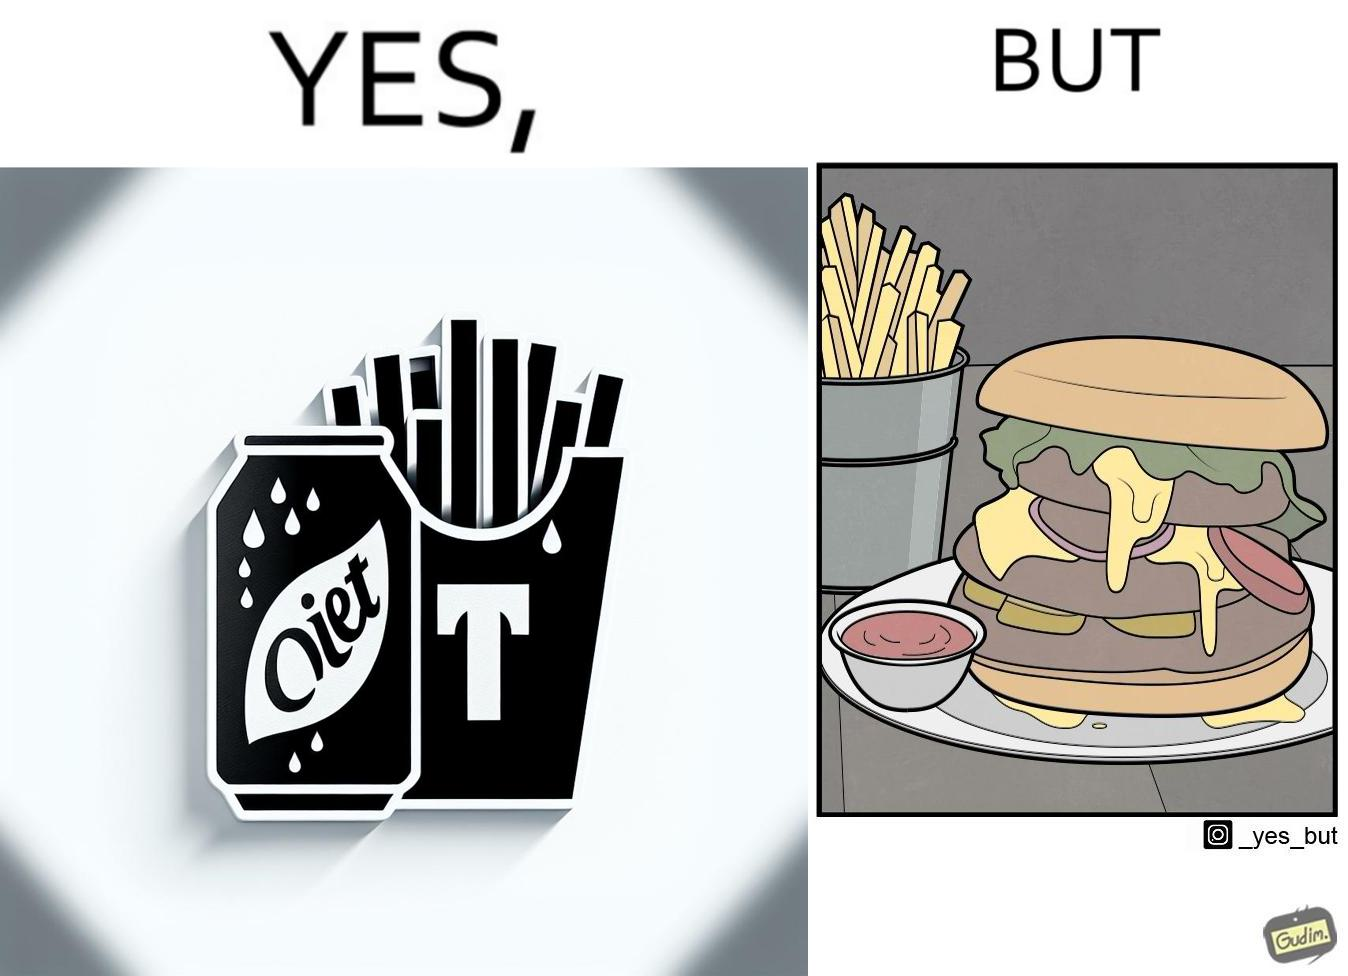Provide a description of this image. The image is ironic, because on one hand the person is consuming diet cola suggesting low on sugar as per label meaning the person is health-conscious but on the other hand the same one is having huge size burger with french fries which suggests the person to be health-ignorant 